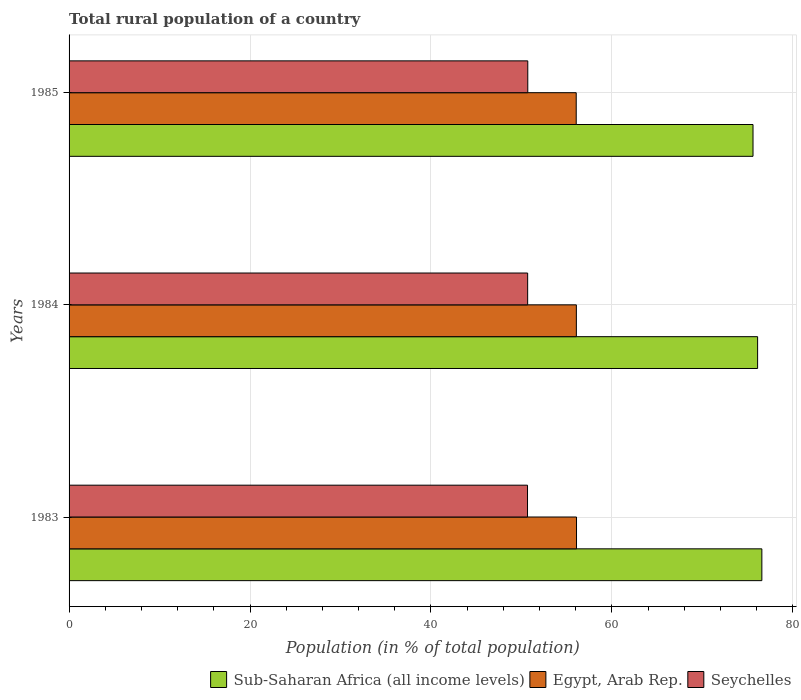How many different coloured bars are there?
Provide a succinct answer. 3. What is the label of the 2nd group of bars from the top?
Provide a short and direct response. 1984. What is the rural population in Egypt, Arab Rep. in 1983?
Your answer should be very brief. 56.09. Across all years, what is the maximum rural population in Egypt, Arab Rep.?
Your answer should be very brief. 56.09. Across all years, what is the minimum rural population in Seychelles?
Your answer should be very brief. 50.68. In which year was the rural population in Seychelles maximum?
Your response must be concise. 1985. In which year was the rural population in Sub-Saharan Africa (all income levels) minimum?
Your response must be concise. 1985. What is the total rural population in Seychelles in the graph?
Provide a succinct answer. 152.08. What is the difference between the rural population in Seychelles in 1983 and that in 1985?
Ensure brevity in your answer.  -0.03. What is the difference between the rural population in Egypt, Arab Rep. in 1985 and the rural population in Sub-Saharan Africa (all income levels) in 1984?
Provide a short and direct response. -20.05. What is the average rural population in Sub-Saharan Africa (all income levels) per year?
Give a very brief answer. 76.1. In the year 1985, what is the difference between the rural population in Seychelles and rural population in Sub-Saharan Africa (all income levels)?
Offer a very short reply. -24.9. In how many years, is the rural population in Sub-Saharan Africa (all income levels) greater than 76 %?
Your answer should be very brief. 2. What is the ratio of the rural population in Seychelles in 1984 to that in 1985?
Your answer should be very brief. 1. What is the difference between the highest and the second highest rural population in Egypt, Arab Rep.?
Your response must be concise. 0.02. What is the difference between the highest and the lowest rural population in Seychelles?
Offer a terse response. 0.03. What does the 2nd bar from the top in 1983 represents?
Give a very brief answer. Egypt, Arab Rep. What does the 3rd bar from the bottom in 1983 represents?
Offer a terse response. Seychelles. Is it the case that in every year, the sum of the rural population in Sub-Saharan Africa (all income levels) and rural population in Seychelles is greater than the rural population in Egypt, Arab Rep.?
Your response must be concise. Yes. How many bars are there?
Your answer should be very brief. 9. Are all the bars in the graph horizontal?
Your response must be concise. Yes. How many years are there in the graph?
Your answer should be very brief. 3. What is the difference between two consecutive major ticks on the X-axis?
Your answer should be very brief. 20. Does the graph contain grids?
Your answer should be compact. Yes. Where does the legend appear in the graph?
Your answer should be compact. Bottom right. How are the legend labels stacked?
Provide a short and direct response. Horizontal. What is the title of the graph?
Ensure brevity in your answer.  Total rural population of a country. Does "China" appear as one of the legend labels in the graph?
Your answer should be compact. No. What is the label or title of the X-axis?
Keep it short and to the point. Population (in % of total population). What is the label or title of the Y-axis?
Your answer should be compact. Years. What is the Population (in % of total population) in Sub-Saharan Africa (all income levels) in 1983?
Keep it short and to the point. 76.58. What is the Population (in % of total population) in Egypt, Arab Rep. in 1983?
Offer a terse response. 56.09. What is the Population (in % of total population) in Seychelles in 1983?
Your answer should be compact. 50.68. What is the Population (in % of total population) of Sub-Saharan Africa (all income levels) in 1984?
Your answer should be compact. 76.11. What is the Population (in % of total population) in Egypt, Arab Rep. in 1984?
Make the answer very short. 56.08. What is the Population (in % of total population) in Seychelles in 1984?
Your answer should be very brief. 50.69. What is the Population (in % of total population) in Sub-Saharan Africa (all income levels) in 1985?
Provide a short and direct response. 75.61. What is the Population (in % of total population) of Egypt, Arab Rep. in 1985?
Offer a very short reply. 56.06. What is the Population (in % of total population) of Seychelles in 1985?
Provide a short and direct response. 50.71. Across all years, what is the maximum Population (in % of total population) in Sub-Saharan Africa (all income levels)?
Ensure brevity in your answer.  76.58. Across all years, what is the maximum Population (in % of total population) in Egypt, Arab Rep.?
Your answer should be very brief. 56.09. Across all years, what is the maximum Population (in % of total population) in Seychelles?
Make the answer very short. 50.71. Across all years, what is the minimum Population (in % of total population) in Sub-Saharan Africa (all income levels)?
Provide a succinct answer. 75.61. Across all years, what is the minimum Population (in % of total population) in Egypt, Arab Rep.?
Keep it short and to the point. 56.06. Across all years, what is the minimum Population (in % of total population) in Seychelles?
Provide a succinct answer. 50.68. What is the total Population (in % of total population) of Sub-Saharan Africa (all income levels) in the graph?
Your answer should be compact. 228.3. What is the total Population (in % of total population) of Egypt, Arab Rep. in the graph?
Make the answer very short. 168.23. What is the total Population (in % of total population) in Seychelles in the graph?
Your answer should be compact. 152.08. What is the difference between the Population (in % of total population) of Sub-Saharan Africa (all income levels) in 1983 and that in 1984?
Give a very brief answer. 0.47. What is the difference between the Population (in % of total population) in Egypt, Arab Rep. in 1983 and that in 1984?
Give a very brief answer. 0.02. What is the difference between the Population (in % of total population) of Seychelles in 1983 and that in 1984?
Your answer should be very brief. -0.01. What is the difference between the Population (in % of total population) of Sub-Saharan Africa (all income levels) in 1983 and that in 1985?
Offer a terse response. 0.98. What is the difference between the Population (in % of total population) of Egypt, Arab Rep. in 1983 and that in 1985?
Provide a succinct answer. 0.03. What is the difference between the Population (in % of total population) of Seychelles in 1983 and that in 1985?
Your response must be concise. -0.03. What is the difference between the Population (in % of total population) in Sub-Saharan Africa (all income levels) in 1984 and that in 1985?
Keep it short and to the point. 0.51. What is the difference between the Population (in % of total population) in Egypt, Arab Rep. in 1984 and that in 1985?
Ensure brevity in your answer.  0.02. What is the difference between the Population (in % of total population) of Seychelles in 1984 and that in 1985?
Keep it short and to the point. -0.01. What is the difference between the Population (in % of total population) in Sub-Saharan Africa (all income levels) in 1983 and the Population (in % of total population) in Egypt, Arab Rep. in 1984?
Give a very brief answer. 20.5. What is the difference between the Population (in % of total population) in Sub-Saharan Africa (all income levels) in 1983 and the Population (in % of total population) in Seychelles in 1984?
Your response must be concise. 25.89. What is the difference between the Population (in % of total population) of Egypt, Arab Rep. in 1983 and the Population (in % of total population) of Seychelles in 1984?
Keep it short and to the point. 5.4. What is the difference between the Population (in % of total population) of Sub-Saharan Africa (all income levels) in 1983 and the Population (in % of total population) of Egypt, Arab Rep. in 1985?
Offer a terse response. 20.52. What is the difference between the Population (in % of total population) of Sub-Saharan Africa (all income levels) in 1983 and the Population (in % of total population) of Seychelles in 1985?
Offer a terse response. 25.87. What is the difference between the Population (in % of total population) of Egypt, Arab Rep. in 1983 and the Population (in % of total population) of Seychelles in 1985?
Ensure brevity in your answer.  5.39. What is the difference between the Population (in % of total population) of Sub-Saharan Africa (all income levels) in 1984 and the Population (in % of total population) of Egypt, Arab Rep. in 1985?
Ensure brevity in your answer.  20.05. What is the difference between the Population (in % of total population) in Sub-Saharan Africa (all income levels) in 1984 and the Population (in % of total population) in Seychelles in 1985?
Your response must be concise. 25.4. What is the difference between the Population (in % of total population) in Egypt, Arab Rep. in 1984 and the Population (in % of total population) in Seychelles in 1985?
Offer a very short reply. 5.37. What is the average Population (in % of total population) in Sub-Saharan Africa (all income levels) per year?
Your answer should be very brief. 76.1. What is the average Population (in % of total population) of Egypt, Arab Rep. per year?
Ensure brevity in your answer.  56.08. What is the average Population (in % of total population) in Seychelles per year?
Keep it short and to the point. 50.69. In the year 1983, what is the difference between the Population (in % of total population) of Sub-Saharan Africa (all income levels) and Population (in % of total population) of Egypt, Arab Rep.?
Offer a terse response. 20.49. In the year 1983, what is the difference between the Population (in % of total population) of Sub-Saharan Africa (all income levels) and Population (in % of total population) of Seychelles?
Your response must be concise. 25.9. In the year 1983, what is the difference between the Population (in % of total population) in Egypt, Arab Rep. and Population (in % of total population) in Seychelles?
Your answer should be very brief. 5.42. In the year 1984, what is the difference between the Population (in % of total population) of Sub-Saharan Africa (all income levels) and Population (in % of total population) of Egypt, Arab Rep.?
Give a very brief answer. 20.03. In the year 1984, what is the difference between the Population (in % of total population) of Sub-Saharan Africa (all income levels) and Population (in % of total population) of Seychelles?
Give a very brief answer. 25.42. In the year 1984, what is the difference between the Population (in % of total population) in Egypt, Arab Rep. and Population (in % of total population) in Seychelles?
Provide a succinct answer. 5.38. In the year 1985, what is the difference between the Population (in % of total population) of Sub-Saharan Africa (all income levels) and Population (in % of total population) of Egypt, Arab Rep.?
Provide a succinct answer. 19.54. In the year 1985, what is the difference between the Population (in % of total population) in Sub-Saharan Africa (all income levels) and Population (in % of total population) in Seychelles?
Your response must be concise. 24.9. In the year 1985, what is the difference between the Population (in % of total population) of Egypt, Arab Rep. and Population (in % of total population) of Seychelles?
Provide a succinct answer. 5.35. What is the ratio of the Population (in % of total population) of Sub-Saharan Africa (all income levels) in 1983 to that in 1984?
Keep it short and to the point. 1.01. What is the ratio of the Population (in % of total population) of Sub-Saharan Africa (all income levels) in 1983 to that in 1985?
Your answer should be very brief. 1.01. What is the difference between the highest and the second highest Population (in % of total population) of Sub-Saharan Africa (all income levels)?
Offer a very short reply. 0.47. What is the difference between the highest and the second highest Population (in % of total population) in Egypt, Arab Rep.?
Ensure brevity in your answer.  0.02. What is the difference between the highest and the second highest Population (in % of total population) in Seychelles?
Your response must be concise. 0.01. What is the difference between the highest and the lowest Population (in % of total population) of Sub-Saharan Africa (all income levels)?
Ensure brevity in your answer.  0.98. What is the difference between the highest and the lowest Population (in % of total population) of Egypt, Arab Rep.?
Your answer should be compact. 0.03. What is the difference between the highest and the lowest Population (in % of total population) of Seychelles?
Provide a short and direct response. 0.03. 